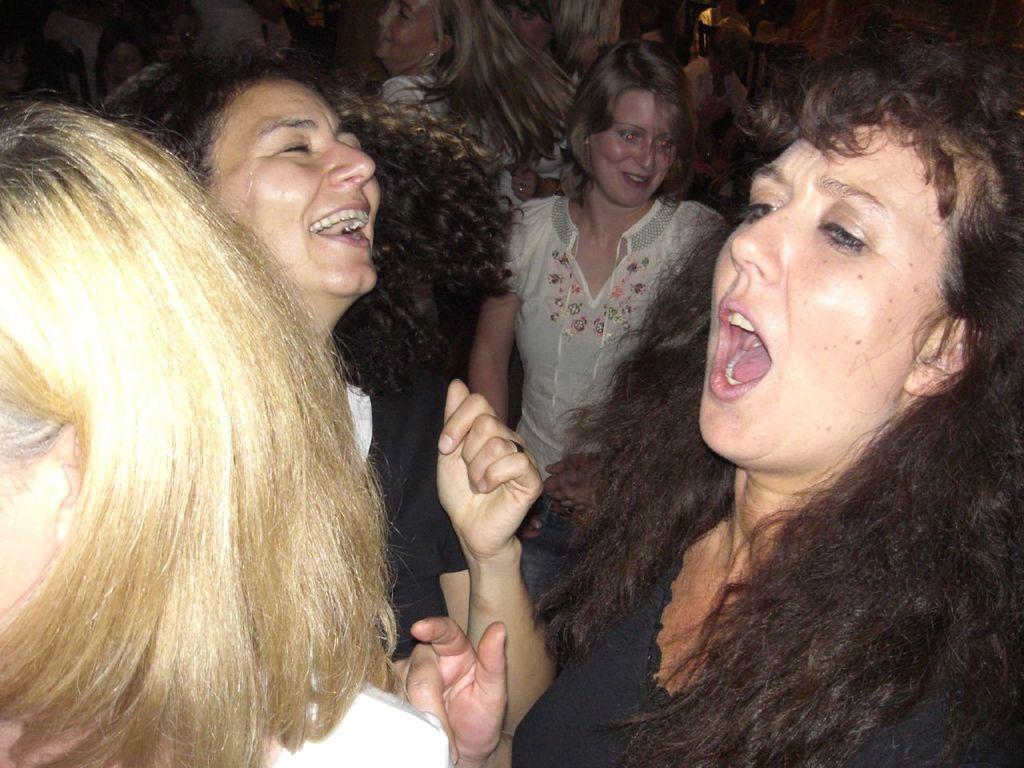In one or two sentences, can you explain what this image depicts? In this picture I can see a group of women are smiling. 